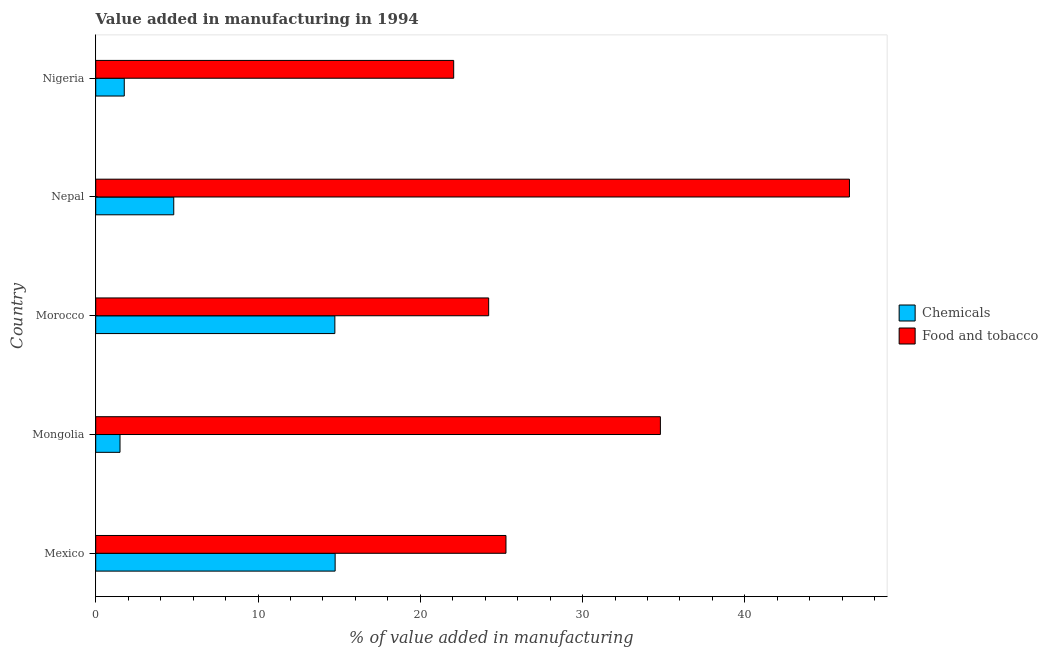How many groups of bars are there?
Provide a short and direct response. 5. Are the number of bars on each tick of the Y-axis equal?
Keep it short and to the point. Yes. How many bars are there on the 2nd tick from the top?
Your answer should be very brief. 2. What is the label of the 1st group of bars from the top?
Provide a short and direct response. Nigeria. What is the value added by manufacturing food and tobacco in Nigeria?
Provide a short and direct response. 22.06. Across all countries, what is the maximum value added by  manufacturing chemicals?
Provide a succinct answer. 14.75. Across all countries, what is the minimum value added by  manufacturing chemicals?
Make the answer very short. 1.5. In which country was the value added by manufacturing food and tobacco maximum?
Your answer should be compact. Nepal. In which country was the value added by  manufacturing chemicals minimum?
Offer a terse response. Mongolia. What is the total value added by  manufacturing chemicals in the graph?
Ensure brevity in your answer.  37.55. What is the difference between the value added by  manufacturing chemicals in Morocco and that in Nepal?
Your response must be concise. 9.93. What is the difference between the value added by  manufacturing chemicals in Mexico and the value added by manufacturing food and tobacco in Morocco?
Keep it short and to the point. -9.46. What is the average value added by manufacturing food and tobacco per country?
Provide a succinct answer. 30.56. What is the difference between the value added by manufacturing food and tobacco and value added by  manufacturing chemicals in Morocco?
Your answer should be compact. 9.48. What is the ratio of the value added by manufacturing food and tobacco in Mexico to that in Nigeria?
Your answer should be very brief. 1.15. Is the value added by  manufacturing chemicals in Morocco less than that in Nigeria?
Offer a very short reply. No. What is the difference between the highest and the second highest value added by manufacturing food and tobacco?
Your answer should be compact. 11.65. What is the difference between the highest and the lowest value added by  manufacturing chemicals?
Ensure brevity in your answer.  13.26. In how many countries, is the value added by manufacturing food and tobacco greater than the average value added by manufacturing food and tobacco taken over all countries?
Your answer should be compact. 2. What does the 1st bar from the top in Nepal represents?
Offer a terse response. Food and tobacco. What does the 2nd bar from the bottom in Nigeria represents?
Offer a terse response. Food and tobacco. Are all the bars in the graph horizontal?
Ensure brevity in your answer.  Yes. Does the graph contain grids?
Provide a succinct answer. No. How many legend labels are there?
Ensure brevity in your answer.  2. How are the legend labels stacked?
Offer a very short reply. Vertical. What is the title of the graph?
Provide a short and direct response. Value added in manufacturing in 1994. Does "By country of asylum" appear as one of the legend labels in the graph?
Provide a succinct answer. No. What is the label or title of the X-axis?
Your response must be concise. % of value added in manufacturing. What is the label or title of the Y-axis?
Your answer should be compact. Country. What is the % of value added in manufacturing in Chemicals in Mexico?
Offer a very short reply. 14.75. What is the % of value added in manufacturing in Food and tobacco in Mexico?
Offer a terse response. 25.28. What is the % of value added in manufacturing in Chemicals in Mongolia?
Provide a succinct answer. 1.5. What is the % of value added in manufacturing of Food and tobacco in Mongolia?
Give a very brief answer. 34.79. What is the % of value added in manufacturing in Chemicals in Morocco?
Offer a very short reply. 14.74. What is the % of value added in manufacturing in Food and tobacco in Morocco?
Keep it short and to the point. 24.21. What is the % of value added in manufacturing of Chemicals in Nepal?
Provide a succinct answer. 4.81. What is the % of value added in manufacturing of Food and tobacco in Nepal?
Your answer should be compact. 46.44. What is the % of value added in manufacturing of Chemicals in Nigeria?
Make the answer very short. 1.76. What is the % of value added in manufacturing of Food and tobacco in Nigeria?
Your answer should be compact. 22.06. Across all countries, what is the maximum % of value added in manufacturing of Chemicals?
Offer a very short reply. 14.75. Across all countries, what is the maximum % of value added in manufacturing of Food and tobacco?
Your answer should be very brief. 46.44. Across all countries, what is the minimum % of value added in manufacturing in Chemicals?
Your response must be concise. 1.5. Across all countries, what is the minimum % of value added in manufacturing in Food and tobacco?
Provide a succinct answer. 22.06. What is the total % of value added in manufacturing in Chemicals in the graph?
Your answer should be compact. 37.55. What is the total % of value added in manufacturing in Food and tobacco in the graph?
Provide a short and direct response. 152.79. What is the difference between the % of value added in manufacturing of Chemicals in Mexico and that in Mongolia?
Keep it short and to the point. 13.26. What is the difference between the % of value added in manufacturing in Food and tobacco in Mexico and that in Mongolia?
Your response must be concise. -9.52. What is the difference between the % of value added in manufacturing of Chemicals in Mexico and that in Morocco?
Provide a succinct answer. 0.02. What is the difference between the % of value added in manufacturing of Food and tobacco in Mexico and that in Morocco?
Ensure brevity in your answer.  1.07. What is the difference between the % of value added in manufacturing of Chemicals in Mexico and that in Nepal?
Ensure brevity in your answer.  9.94. What is the difference between the % of value added in manufacturing in Food and tobacco in Mexico and that in Nepal?
Your answer should be compact. -21.16. What is the difference between the % of value added in manufacturing in Chemicals in Mexico and that in Nigeria?
Make the answer very short. 12.99. What is the difference between the % of value added in manufacturing in Food and tobacco in Mexico and that in Nigeria?
Your response must be concise. 3.22. What is the difference between the % of value added in manufacturing of Chemicals in Mongolia and that in Morocco?
Keep it short and to the point. -13.24. What is the difference between the % of value added in manufacturing of Food and tobacco in Mongolia and that in Morocco?
Provide a succinct answer. 10.58. What is the difference between the % of value added in manufacturing in Chemicals in Mongolia and that in Nepal?
Your response must be concise. -3.31. What is the difference between the % of value added in manufacturing in Food and tobacco in Mongolia and that in Nepal?
Make the answer very short. -11.65. What is the difference between the % of value added in manufacturing in Chemicals in Mongolia and that in Nigeria?
Your response must be concise. -0.26. What is the difference between the % of value added in manufacturing in Food and tobacco in Mongolia and that in Nigeria?
Ensure brevity in your answer.  12.74. What is the difference between the % of value added in manufacturing of Chemicals in Morocco and that in Nepal?
Keep it short and to the point. 9.93. What is the difference between the % of value added in manufacturing in Food and tobacco in Morocco and that in Nepal?
Your answer should be compact. -22.23. What is the difference between the % of value added in manufacturing of Chemicals in Morocco and that in Nigeria?
Your response must be concise. 12.98. What is the difference between the % of value added in manufacturing of Food and tobacco in Morocco and that in Nigeria?
Offer a terse response. 2.16. What is the difference between the % of value added in manufacturing in Chemicals in Nepal and that in Nigeria?
Your answer should be very brief. 3.05. What is the difference between the % of value added in manufacturing of Food and tobacco in Nepal and that in Nigeria?
Keep it short and to the point. 24.39. What is the difference between the % of value added in manufacturing of Chemicals in Mexico and the % of value added in manufacturing of Food and tobacco in Mongolia?
Give a very brief answer. -20.04. What is the difference between the % of value added in manufacturing of Chemicals in Mexico and the % of value added in manufacturing of Food and tobacco in Morocco?
Offer a very short reply. -9.46. What is the difference between the % of value added in manufacturing of Chemicals in Mexico and the % of value added in manufacturing of Food and tobacco in Nepal?
Your answer should be compact. -31.69. What is the difference between the % of value added in manufacturing in Chemicals in Mexico and the % of value added in manufacturing in Food and tobacco in Nigeria?
Provide a succinct answer. -7.31. What is the difference between the % of value added in manufacturing of Chemicals in Mongolia and the % of value added in manufacturing of Food and tobacco in Morocco?
Provide a short and direct response. -22.72. What is the difference between the % of value added in manufacturing of Chemicals in Mongolia and the % of value added in manufacturing of Food and tobacco in Nepal?
Offer a terse response. -44.95. What is the difference between the % of value added in manufacturing in Chemicals in Mongolia and the % of value added in manufacturing in Food and tobacco in Nigeria?
Your answer should be compact. -20.56. What is the difference between the % of value added in manufacturing in Chemicals in Morocco and the % of value added in manufacturing in Food and tobacco in Nepal?
Offer a terse response. -31.71. What is the difference between the % of value added in manufacturing of Chemicals in Morocco and the % of value added in manufacturing of Food and tobacco in Nigeria?
Keep it short and to the point. -7.32. What is the difference between the % of value added in manufacturing in Chemicals in Nepal and the % of value added in manufacturing in Food and tobacco in Nigeria?
Ensure brevity in your answer.  -17.25. What is the average % of value added in manufacturing of Chemicals per country?
Provide a short and direct response. 7.51. What is the average % of value added in manufacturing of Food and tobacco per country?
Provide a short and direct response. 30.56. What is the difference between the % of value added in manufacturing in Chemicals and % of value added in manufacturing in Food and tobacco in Mexico?
Keep it short and to the point. -10.53. What is the difference between the % of value added in manufacturing in Chemicals and % of value added in manufacturing in Food and tobacco in Mongolia?
Provide a succinct answer. -33.3. What is the difference between the % of value added in manufacturing of Chemicals and % of value added in manufacturing of Food and tobacco in Morocco?
Your response must be concise. -9.48. What is the difference between the % of value added in manufacturing of Chemicals and % of value added in manufacturing of Food and tobacco in Nepal?
Ensure brevity in your answer.  -41.63. What is the difference between the % of value added in manufacturing in Chemicals and % of value added in manufacturing in Food and tobacco in Nigeria?
Your answer should be compact. -20.3. What is the ratio of the % of value added in manufacturing of Chemicals in Mexico to that in Mongolia?
Offer a very short reply. 9.85. What is the ratio of the % of value added in manufacturing in Food and tobacco in Mexico to that in Mongolia?
Your answer should be very brief. 0.73. What is the ratio of the % of value added in manufacturing of Food and tobacco in Mexico to that in Morocco?
Provide a short and direct response. 1.04. What is the ratio of the % of value added in manufacturing in Chemicals in Mexico to that in Nepal?
Your answer should be compact. 3.07. What is the ratio of the % of value added in manufacturing of Food and tobacco in Mexico to that in Nepal?
Give a very brief answer. 0.54. What is the ratio of the % of value added in manufacturing of Chemicals in Mexico to that in Nigeria?
Your answer should be very brief. 8.38. What is the ratio of the % of value added in manufacturing in Food and tobacco in Mexico to that in Nigeria?
Keep it short and to the point. 1.15. What is the ratio of the % of value added in manufacturing of Chemicals in Mongolia to that in Morocco?
Ensure brevity in your answer.  0.1. What is the ratio of the % of value added in manufacturing in Food and tobacco in Mongolia to that in Morocco?
Provide a short and direct response. 1.44. What is the ratio of the % of value added in manufacturing of Chemicals in Mongolia to that in Nepal?
Make the answer very short. 0.31. What is the ratio of the % of value added in manufacturing of Food and tobacco in Mongolia to that in Nepal?
Provide a short and direct response. 0.75. What is the ratio of the % of value added in manufacturing in Chemicals in Mongolia to that in Nigeria?
Provide a short and direct response. 0.85. What is the ratio of the % of value added in manufacturing in Food and tobacco in Mongolia to that in Nigeria?
Provide a short and direct response. 1.58. What is the ratio of the % of value added in manufacturing of Chemicals in Morocco to that in Nepal?
Ensure brevity in your answer.  3.06. What is the ratio of the % of value added in manufacturing of Food and tobacco in Morocco to that in Nepal?
Your response must be concise. 0.52. What is the ratio of the % of value added in manufacturing of Chemicals in Morocco to that in Nigeria?
Keep it short and to the point. 8.37. What is the ratio of the % of value added in manufacturing of Food and tobacco in Morocco to that in Nigeria?
Provide a short and direct response. 1.1. What is the ratio of the % of value added in manufacturing in Chemicals in Nepal to that in Nigeria?
Your response must be concise. 2.73. What is the ratio of the % of value added in manufacturing in Food and tobacco in Nepal to that in Nigeria?
Offer a very short reply. 2.11. What is the difference between the highest and the second highest % of value added in manufacturing in Chemicals?
Provide a succinct answer. 0.02. What is the difference between the highest and the second highest % of value added in manufacturing in Food and tobacco?
Ensure brevity in your answer.  11.65. What is the difference between the highest and the lowest % of value added in manufacturing in Chemicals?
Provide a short and direct response. 13.26. What is the difference between the highest and the lowest % of value added in manufacturing in Food and tobacco?
Ensure brevity in your answer.  24.39. 